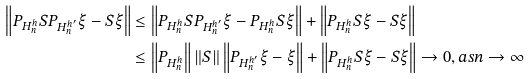<formula> <loc_0><loc_0><loc_500><loc_500>\left \| P _ { H _ { n } ^ { h } } S P _ { H _ { n } ^ { h ^ { \prime } } } \xi - S \xi \right \| & \leq \left \| P _ { H _ { n } ^ { h } } S P _ { H _ { n } ^ { h ^ { \prime } } } \xi - P _ { H _ { n } ^ { h } } S \xi \right \| + \left \| P _ { H _ { n } ^ { h } } S \xi - S \xi \right \| \\ & \leq \left \| P _ { H _ { n } ^ { h } } \right \| \left \| S \right \| \left \| P _ { H _ { n } ^ { h ^ { \prime } } } \xi - \xi \right \| + \left \| P _ { H _ { n } ^ { h } } S \xi - S \xi \right \| \rightarrow 0 , a s n \rightarrow \infty</formula> 